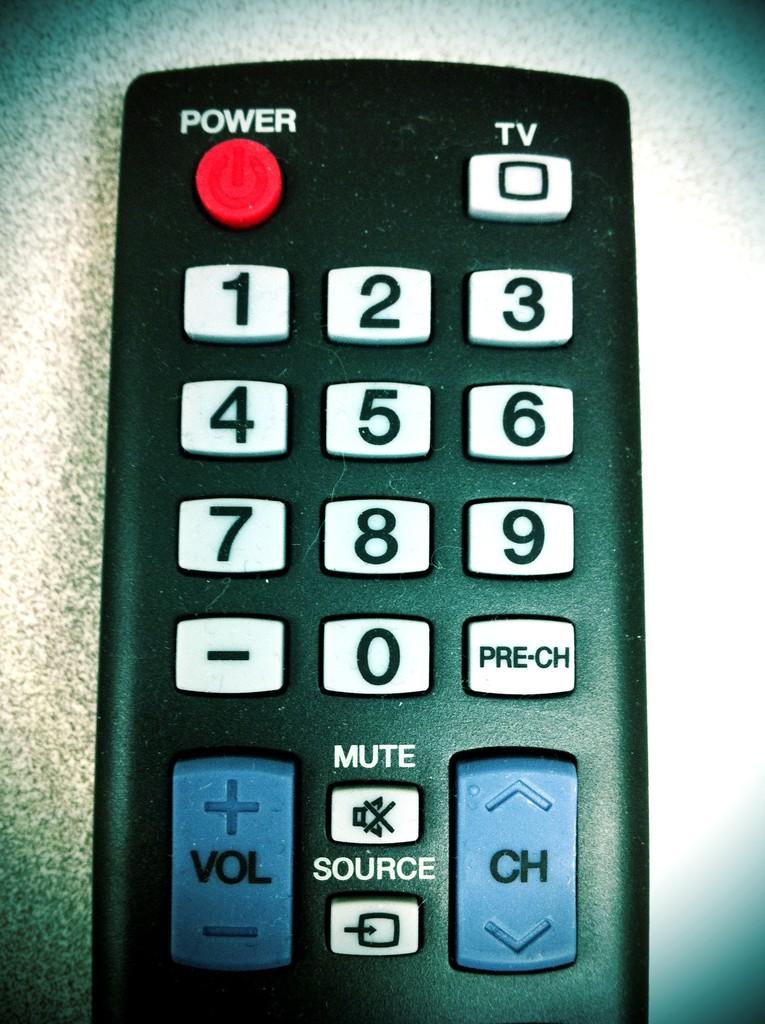What would you press to go to the last channel you watched?
Give a very brief answer. Pre-ch. What word is above the red button?
Provide a succinct answer. Power. 